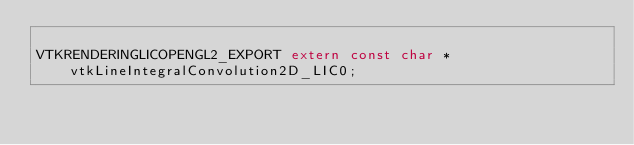Convert code to text. <code><loc_0><loc_0><loc_500><loc_500><_C_>
VTKRENDERINGLICOPENGL2_EXPORT extern const char *vtkLineIntegralConvolution2D_LIC0;
</code> 